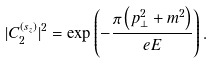Convert formula to latex. <formula><loc_0><loc_0><loc_500><loc_500>| C _ { 2 } ^ { ( s _ { z } ) } | ^ { 2 } = \exp \left ( - \frac { \pi \left ( p ^ { 2 } _ { \bot } + m ^ { 2 } \right ) } { e E } \right ) .</formula> 